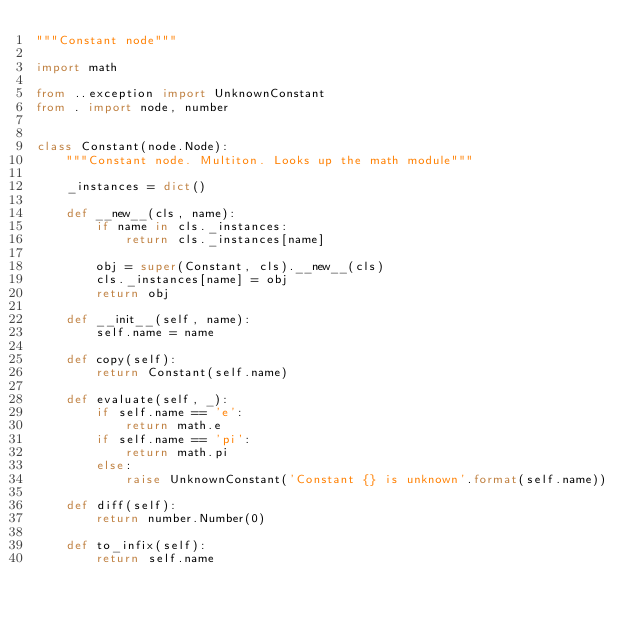Convert code to text. <code><loc_0><loc_0><loc_500><loc_500><_Python_>"""Constant node"""

import math

from ..exception import UnknownConstant
from . import node, number


class Constant(node.Node):
    """Constant node. Multiton. Looks up the math module"""

    _instances = dict()

    def __new__(cls, name):
        if name in cls._instances:
            return cls._instances[name]

        obj = super(Constant, cls).__new__(cls)
        cls._instances[name] = obj
        return obj

    def __init__(self, name):
        self.name = name

    def copy(self):
        return Constant(self.name)

    def evaluate(self, _):
        if self.name == 'e':
            return math.e
        if self.name == 'pi':
            return math.pi
        else:
            raise UnknownConstant('Constant {} is unknown'.format(self.name))

    def diff(self):
        return number.Number(0)

    def to_infix(self):
        return self.name
</code> 